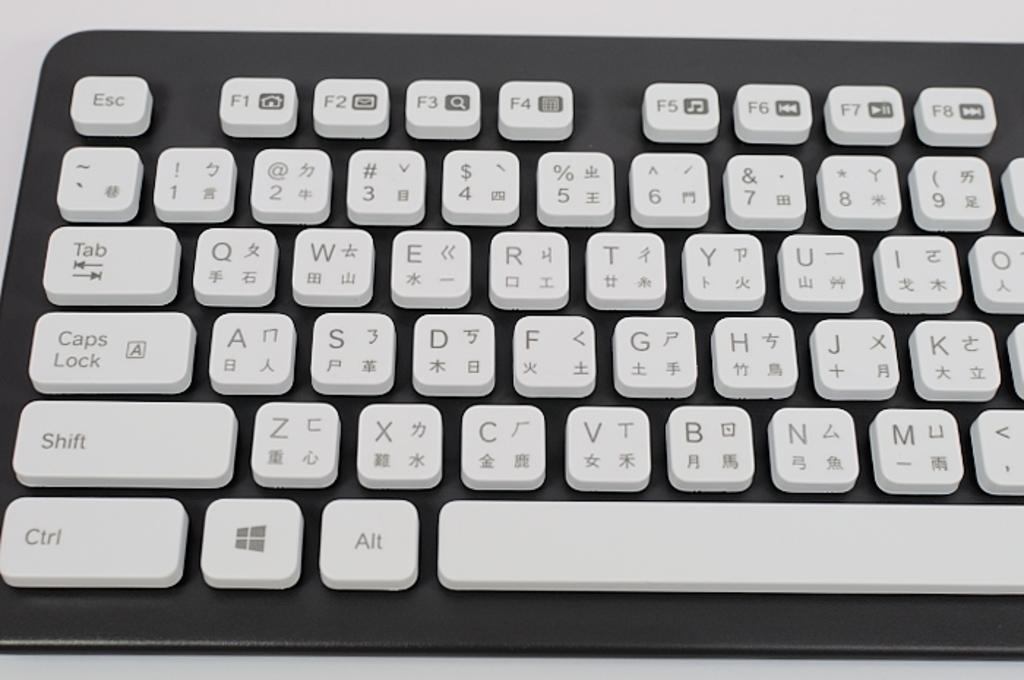<image>
Create a compact narrative representing the image presented. A black keyboard with white keys shows the left side with Esc at the top left. 